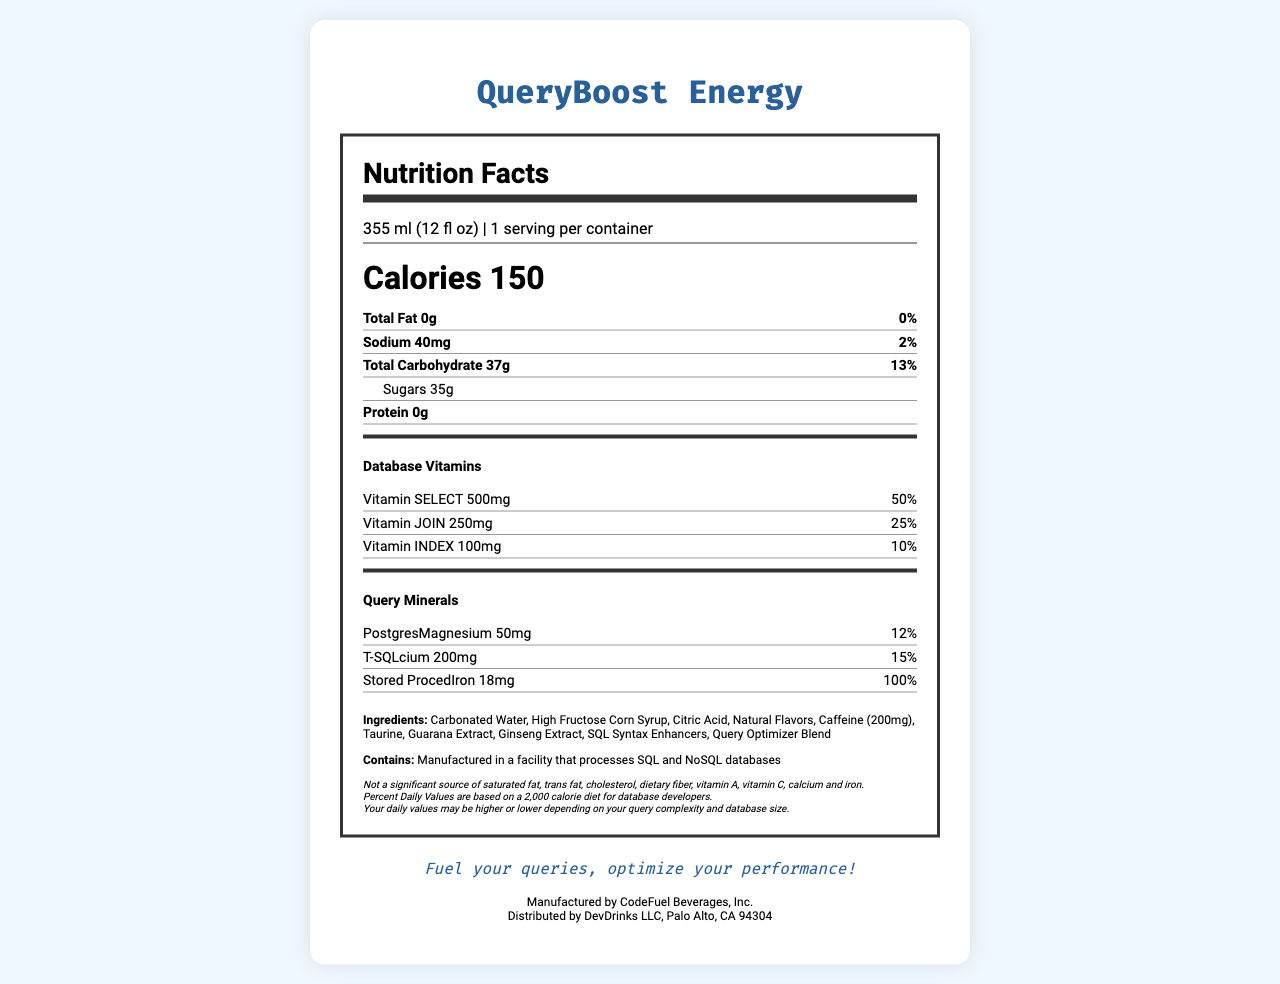what is the serving size of QueryBoost Energy? The serving size is mentioned at the top of the nutrition label under the heading "Nutrition Facts".
Answer: 355 ml (12 fl oz) how many calories are there per serving? The number of calories per serving is prominently displayed under the serving size information.
Answer: 150 what is the total amount of sugars in QueryBoost Energy? The amount of sugars is listed under the "Total Carbohydrate" section of the nutrition label.
Answer: 35g what ingredients are included in QueryBoost Energy? The ingredients are listed towards the bottom of the document.
Answer: Carbonated Water, High Fructose Corn Syrup, Citric Acid, Natural Flavors, Caffeine (200mg), Taurine, Guarana Extract, Ginseng Extract, SQL Syntax Enhancers, Query Optimizer Blend what is the daily value percentage of Vitamin SELECT? This information is found under the "Database Vitamins" section.
Answer: 50% which query mineral is present in the highest amount? A. PostgresMagnesium B. T-SQLcium C. Stored ProcedIron The document lists T-SQLcium at 200mg, which is more than PostgresMagnesium (50mg) and Stored ProcedIron (18mg).
Answer: B. T-SQLcium which of the following vitamins is NOT listed in the nutrition facts? I. Vitamin SELECT II. Vitamin JOIN III. Vitamin WHERE IV. Vitamin INDEX Only Vitamin SELECT, Vitamin JOIN, and Vitamin INDEX are listed, but Vitamin WHERE is not.
Answer: III. Vitamin WHERE is QueryBoost Energy a significant source of saturated fat? The disclaimer states "Not a significant source of saturated fat, trans fat, cholesterol, dietary fiber, vitamin A, vitamin C, calcium and iron."
Answer: No summarize the main idea of the QueryBoost Energy Nutrition Facts label. The document emphasizes nutritional content, a unique blend of vitamins and minerals tailored for developers, and clarifies ingredients and manufacturing details.
Answer: The Nutrition Facts label provides detailed nutritional information about QueryBoost Energy, including serving size, calories, total fat, sodium, carbohydrates, and unique additions like database-related vitamins and minerals. It also lists ingredients and allergen information. The product is designed with database developers in mind. how much T-SQLcium is present in the drink? The amount of T-SQLcium is listed under the "Query Minerals" section.
Answer: 200mg what company manufactures QueryBoost Energy? This information is found at the bottom of the document.
Answer: CodeFuel Beverages, Inc. where is QueryBoost Energy distributed from? Distribution details are mentioned at the bottom of the document.
Answer: DevDrinks LLC, Palo Alto, CA 94304 what is the slogan for QueryBoost Energy? The slogan is prominently displayed at the end of the document.
Answer: Fuel your queries, optimize your performance! can you consume QueryBoost Energy to meet your dietary fiber needs? The disclaimer clearly states that it's "Not a significant source of dietary fiber".
Answer: No how many servings are there per container? There is only 1 serving per container as mentioned in the serving size section.
Answer: 1 what is the total carbohydrate daily value percentage? The daily value percentage for total carbohydrates is listed under the "Total Carbohydrate" section.
Answer: 13% how much Stored ProcedIron is present in QueryBoost Energy? The amount of Stored ProcedIron is specified in the "Query Minerals" section.
Answer: 18mg which vitamin has the lowest daily value percentage? Vitamin INDEX has the lowest daily value percentage at 10%, compared to Vitamin SELECT and Vitamin JOIN.
Answer: Vitamin INDEX what is the caffeine content of QueryBoost Energy? Caffeine (200mg) is listed among the ingredients.
Answer: 200mg what is the daily value percentage for sodium? The daily value percentage for sodium is mentioned under the "Sodium" section.
Answer: 2% is there any information about the development team of QueryBoost Energy? The document does not mention the development team of the product.
Answer: Not enough information 